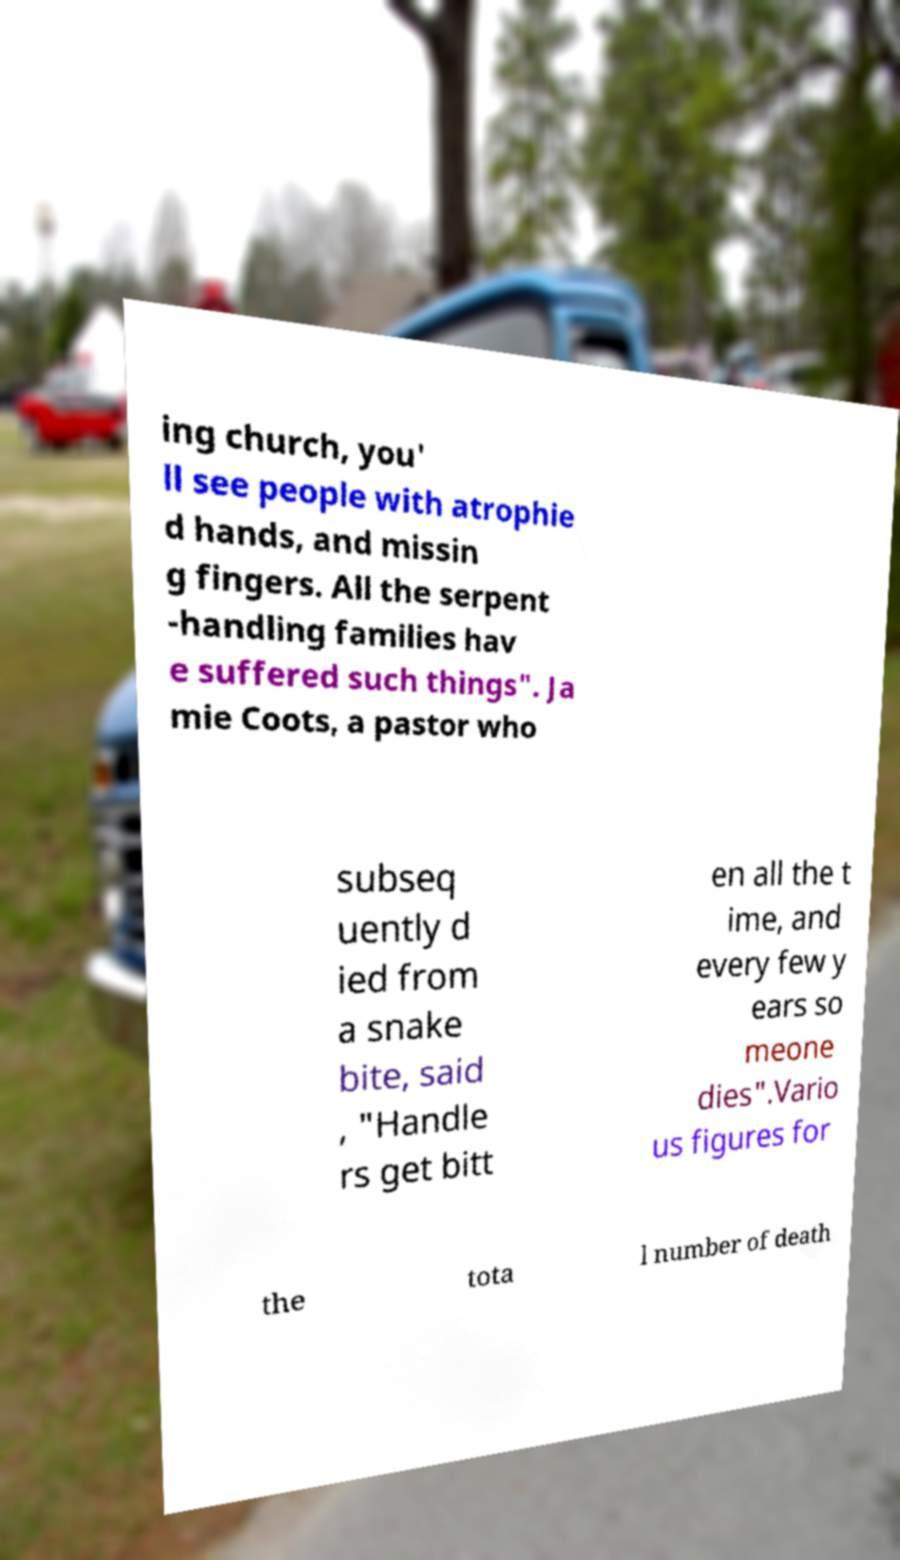Please read and relay the text visible in this image. What does it say? ing church, you' ll see people with atrophie d hands, and missin g fingers. All the serpent -handling families hav e suffered such things". Ja mie Coots, a pastor who subseq uently d ied from a snake bite, said , "Handle rs get bitt en all the t ime, and every few y ears so meone dies".Vario us figures for the tota l number of death 